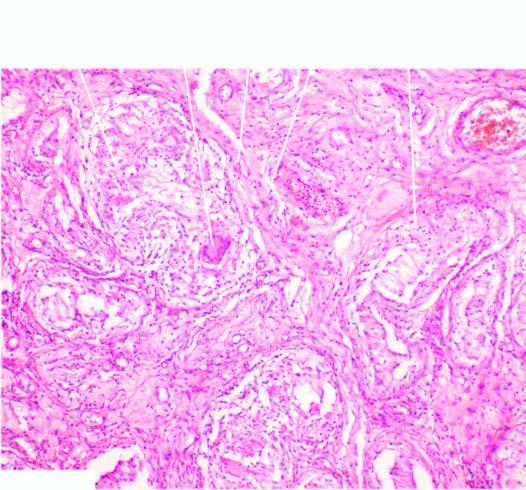what are these granulomas surrounded by?
Answer the question using a single word or phrase. Langhans 'giant cells and mantle of lymphocytes 